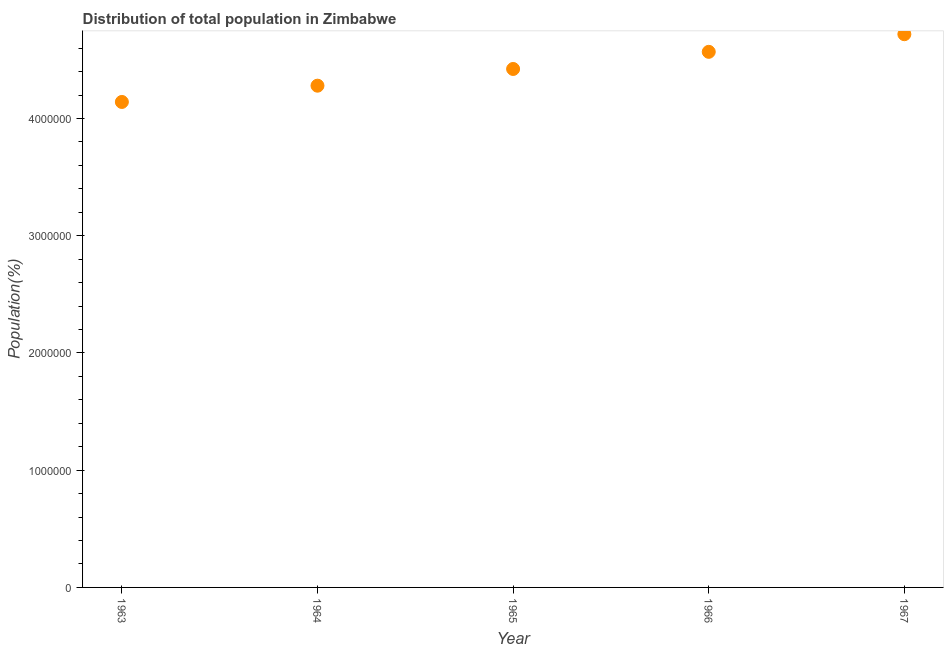What is the population in 1963?
Ensure brevity in your answer.  4.14e+06. Across all years, what is the maximum population?
Provide a succinct answer. 4.72e+06. Across all years, what is the minimum population?
Make the answer very short. 4.14e+06. In which year was the population maximum?
Your answer should be very brief. 1967. In which year was the population minimum?
Provide a succinct answer. 1963. What is the sum of the population?
Offer a very short reply. 2.21e+07. What is the difference between the population in 1965 and 1966?
Keep it short and to the point. -1.46e+05. What is the average population per year?
Provide a short and direct response. 4.43e+06. What is the median population?
Offer a terse response. 4.42e+06. In how many years, is the population greater than 200000 %?
Make the answer very short. 5. Do a majority of the years between 1966 and 1963 (inclusive) have population greater than 3400000 %?
Make the answer very short. Yes. What is the ratio of the population in 1965 to that in 1967?
Keep it short and to the point. 0.94. Is the population in 1965 less than that in 1966?
Ensure brevity in your answer.  Yes. What is the difference between the highest and the second highest population?
Make the answer very short. 1.50e+05. Is the sum of the population in 1964 and 1965 greater than the maximum population across all years?
Your answer should be compact. Yes. What is the difference between the highest and the lowest population?
Give a very brief answer. 5.78e+05. In how many years, is the population greater than the average population taken over all years?
Provide a short and direct response. 2. How many dotlines are there?
Your response must be concise. 1. How many years are there in the graph?
Ensure brevity in your answer.  5. What is the difference between two consecutive major ticks on the Y-axis?
Provide a short and direct response. 1.00e+06. Are the values on the major ticks of Y-axis written in scientific E-notation?
Your response must be concise. No. Does the graph contain any zero values?
Ensure brevity in your answer.  No. Does the graph contain grids?
Make the answer very short. No. What is the title of the graph?
Offer a terse response. Distribution of total population in Zimbabwe . What is the label or title of the Y-axis?
Keep it short and to the point. Population(%). What is the Population(%) in 1963?
Offer a very short reply. 4.14e+06. What is the Population(%) in 1964?
Give a very brief answer. 4.28e+06. What is the Population(%) in 1965?
Give a very brief answer. 4.42e+06. What is the Population(%) in 1966?
Your answer should be compact. 4.57e+06. What is the Population(%) in 1967?
Your answer should be very brief. 4.72e+06. What is the difference between the Population(%) in 1963 and 1964?
Make the answer very short. -1.39e+05. What is the difference between the Population(%) in 1963 and 1965?
Make the answer very short. -2.81e+05. What is the difference between the Population(%) in 1963 and 1966?
Your answer should be very brief. -4.28e+05. What is the difference between the Population(%) in 1963 and 1967?
Your answer should be compact. -5.78e+05. What is the difference between the Population(%) in 1964 and 1965?
Offer a terse response. -1.43e+05. What is the difference between the Population(%) in 1964 and 1966?
Your response must be concise. -2.89e+05. What is the difference between the Population(%) in 1964 and 1967?
Your answer should be very brief. -4.39e+05. What is the difference between the Population(%) in 1965 and 1966?
Provide a succinct answer. -1.46e+05. What is the difference between the Population(%) in 1965 and 1967?
Provide a succinct answer. -2.96e+05. What is the difference between the Population(%) in 1966 and 1967?
Make the answer very short. -1.50e+05. What is the ratio of the Population(%) in 1963 to that in 1965?
Your response must be concise. 0.94. What is the ratio of the Population(%) in 1963 to that in 1966?
Offer a very short reply. 0.91. What is the ratio of the Population(%) in 1963 to that in 1967?
Offer a terse response. 0.88. What is the ratio of the Population(%) in 1964 to that in 1966?
Ensure brevity in your answer.  0.94. What is the ratio of the Population(%) in 1964 to that in 1967?
Give a very brief answer. 0.91. What is the ratio of the Population(%) in 1965 to that in 1966?
Offer a terse response. 0.97. What is the ratio of the Population(%) in 1965 to that in 1967?
Ensure brevity in your answer.  0.94. 